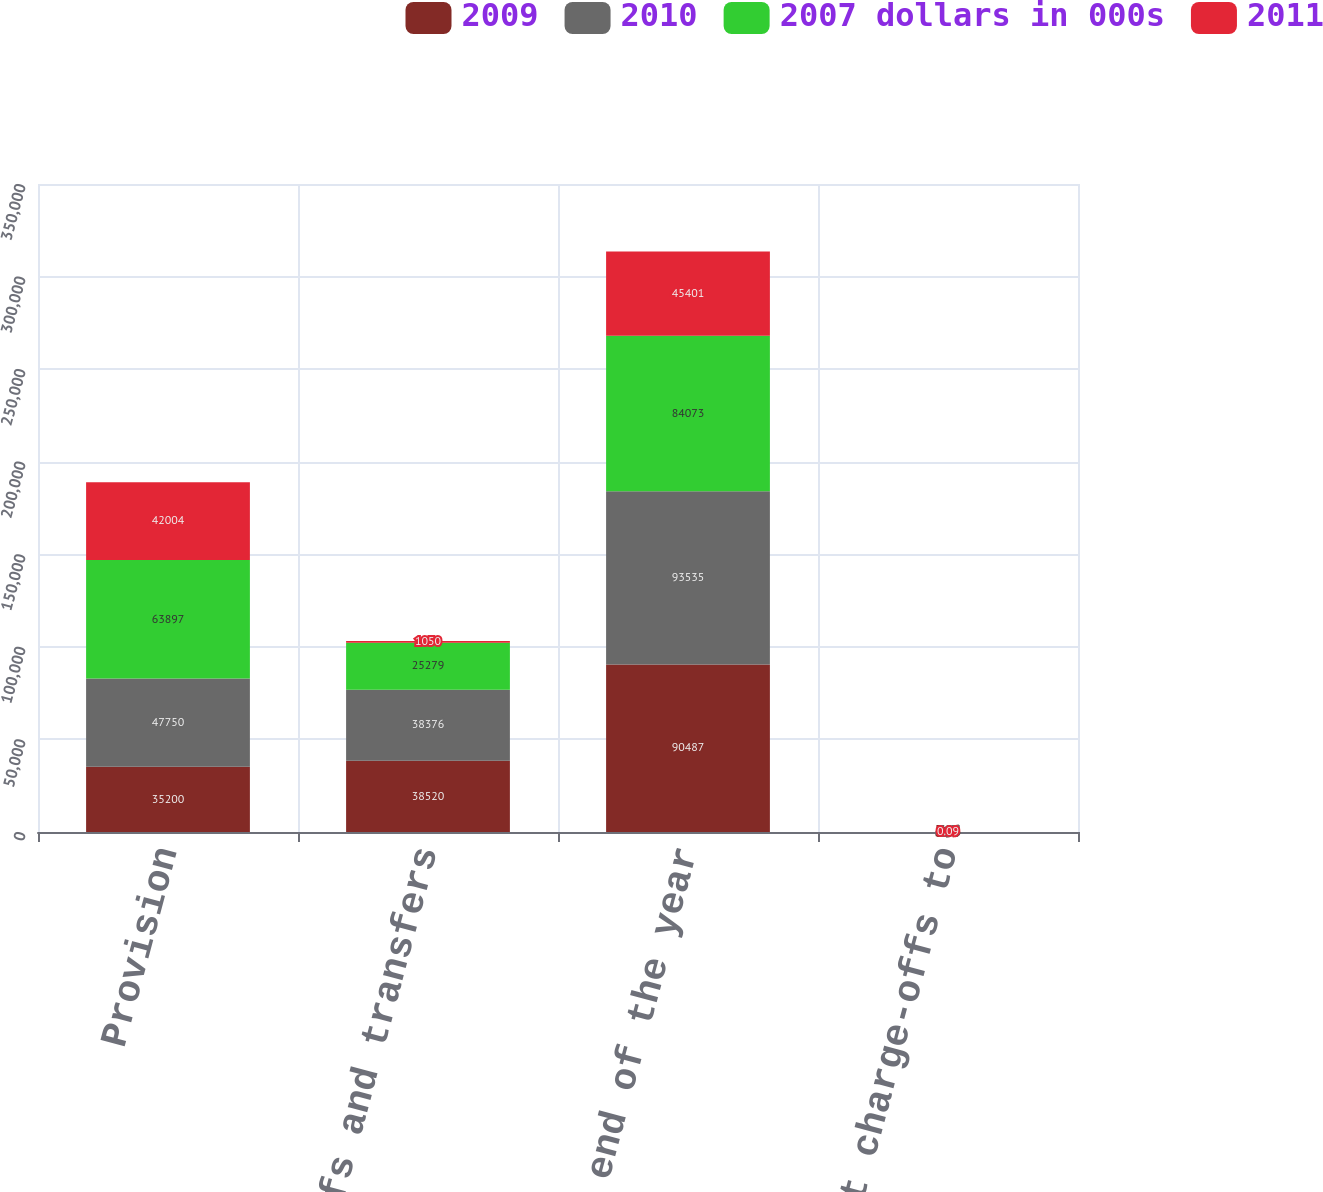Convert chart. <chart><loc_0><loc_0><loc_500><loc_500><stacked_bar_chart><ecel><fcel>Provision<fcel>Charge-offs and transfers<fcel>Balance at end of the year<fcel>Ratio of net charge-offs to<nl><fcel>2009<fcel>35200<fcel>38520<fcel>90487<fcel>5.96<nl><fcel>2010<fcel>47750<fcel>38376<fcel>93535<fcel>4.95<nl><fcel>2007 dollars in 000s<fcel>63897<fcel>25279<fcel>84073<fcel>2.8<nl><fcel>2011<fcel>42004<fcel>1050<fcel>45401<fcel>0.09<nl></chart> 